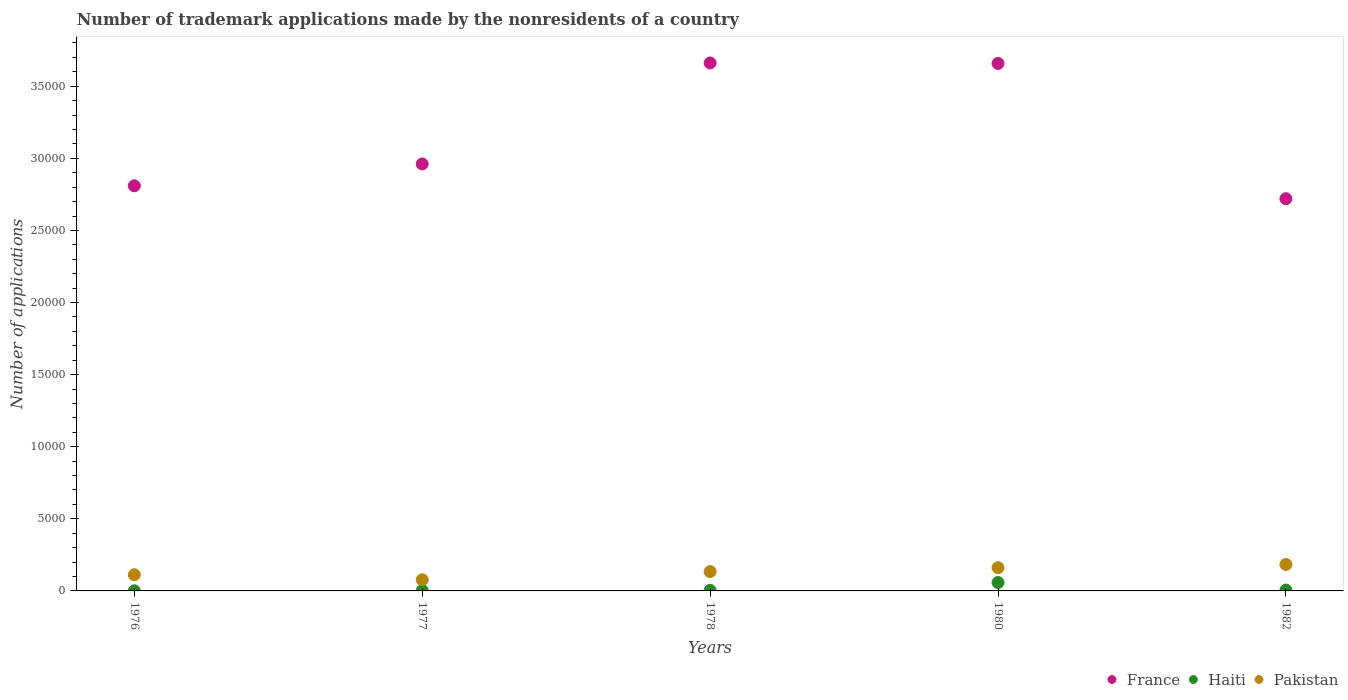Is the number of dotlines equal to the number of legend labels?
Ensure brevity in your answer.  Yes. What is the number of trademark applications made by the nonresidents in France in 1982?
Your answer should be very brief. 2.72e+04. Across all years, what is the maximum number of trademark applications made by the nonresidents in France?
Your response must be concise. 3.66e+04. In which year was the number of trademark applications made by the nonresidents in France maximum?
Ensure brevity in your answer.  1978. In which year was the number of trademark applications made by the nonresidents in Haiti minimum?
Provide a short and direct response. 1976. What is the total number of trademark applications made by the nonresidents in France in the graph?
Offer a terse response. 1.58e+05. What is the difference between the number of trademark applications made by the nonresidents in Pakistan in 1976 and that in 1977?
Offer a very short reply. 347. What is the difference between the number of trademark applications made by the nonresidents in Haiti in 1980 and the number of trademark applications made by the nonresidents in Pakistan in 1976?
Your answer should be compact. -541. What is the average number of trademark applications made by the nonresidents in France per year?
Offer a terse response. 3.16e+04. In the year 1978, what is the difference between the number of trademark applications made by the nonresidents in Haiti and number of trademark applications made by the nonresidents in Pakistan?
Provide a short and direct response. -1304. In how many years, is the number of trademark applications made by the nonresidents in Pakistan greater than 34000?
Give a very brief answer. 0. What is the ratio of the number of trademark applications made by the nonresidents in Haiti in 1977 to that in 1980?
Your answer should be very brief. 0.05. What is the difference between the highest and the lowest number of trademark applications made by the nonresidents in France?
Your response must be concise. 9414. Is the number of trademark applications made by the nonresidents in France strictly greater than the number of trademark applications made by the nonresidents in Pakistan over the years?
Make the answer very short. Yes. How many dotlines are there?
Your answer should be very brief. 3. How many years are there in the graph?
Provide a short and direct response. 5. Are the values on the major ticks of Y-axis written in scientific E-notation?
Your answer should be compact. No. Does the graph contain grids?
Provide a succinct answer. No. How many legend labels are there?
Make the answer very short. 3. How are the legend labels stacked?
Your response must be concise. Horizontal. What is the title of the graph?
Your answer should be very brief. Number of trademark applications made by the nonresidents of a country. What is the label or title of the Y-axis?
Offer a terse response. Number of applications. What is the Number of applications in France in 1976?
Ensure brevity in your answer.  2.81e+04. What is the Number of applications of Pakistan in 1976?
Offer a terse response. 1123. What is the Number of applications of France in 1977?
Your response must be concise. 2.96e+04. What is the Number of applications in Pakistan in 1977?
Your answer should be very brief. 776. What is the Number of applications of France in 1978?
Your answer should be very brief. 3.66e+04. What is the Number of applications of Haiti in 1978?
Your answer should be compact. 36. What is the Number of applications of Pakistan in 1978?
Your answer should be very brief. 1340. What is the Number of applications in France in 1980?
Keep it short and to the point. 3.66e+04. What is the Number of applications in Haiti in 1980?
Ensure brevity in your answer.  582. What is the Number of applications in Pakistan in 1980?
Give a very brief answer. 1611. What is the Number of applications of France in 1982?
Provide a short and direct response. 2.72e+04. What is the Number of applications in Pakistan in 1982?
Ensure brevity in your answer.  1835. Across all years, what is the maximum Number of applications of France?
Give a very brief answer. 3.66e+04. Across all years, what is the maximum Number of applications in Haiti?
Keep it short and to the point. 582. Across all years, what is the maximum Number of applications in Pakistan?
Offer a very short reply. 1835. Across all years, what is the minimum Number of applications of France?
Provide a short and direct response. 2.72e+04. Across all years, what is the minimum Number of applications of Pakistan?
Make the answer very short. 776. What is the total Number of applications of France in the graph?
Keep it short and to the point. 1.58e+05. What is the total Number of applications of Haiti in the graph?
Make the answer very short. 716. What is the total Number of applications of Pakistan in the graph?
Offer a very short reply. 6685. What is the difference between the Number of applications in France in 1976 and that in 1977?
Your answer should be compact. -1515. What is the difference between the Number of applications in Haiti in 1976 and that in 1977?
Your answer should be very brief. -20. What is the difference between the Number of applications in Pakistan in 1976 and that in 1977?
Your answer should be compact. 347. What is the difference between the Number of applications of France in 1976 and that in 1978?
Provide a short and direct response. -8519. What is the difference between the Number of applications in Pakistan in 1976 and that in 1978?
Offer a very short reply. -217. What is the difference between the Number of applications in France in 1976 and that in 1980?
Offer a very short reply. -8485. What is the difference between the Number of applications in Haiti in 1976 and that in 1980?
Make the answer very short. -573. What is the difference between the Number of applications of Pakistan in 1976 and that in 1980?
Your answer should be compact. -488. What is the difference between the Number of applications of France in 1976 and that in 1982?
Provide a succinct answer. 895. What is the difference between the Number of applications in Haiti in 1976 and that in 1982?
Ensure brevity in your answer.  -51. What is the difference between the Number of applications of Pakistan in 1976 and that in 1982?
Keep it short and to the point. -712. What is the difference between the Number of applications in France in 1977 and that in 1978?
Your answer should be compact. -7004. What is the difference between the Number of applications in Pakistan in 1977 and that in 1978?
Make the answer very short. -564. What is the difference between the Number of applications in France in 1977 and that in 1980?
Give a very brief answer. -6970. What is the difference between the Number of applications in Haiti in 1977 and that in 1980?
Your answer should be compact. -553. What is the difference between the Number of applications in Pakistan in 1977 and that in 1980?
Ensure brevity in your answer.  -835. What is the difference between the Number of applications of France in 1977 and that in 1982?
Provide a succinct answer. 2410. What is the difference between the Number of applications of Haiti in 1977 and that in 1982?
Provide a short and direct response. -31. What is the difference between the Number of applications of Pakistan in 1977 and that in 1982?
Your response must be concise. -1059. What is the difference between the Number of applications in Haiti in 1978 and that in 1980?
Give a very brief answer. -546. What is the difference between the Number of applications of Pakistan in 1978 and that in 1980?
Your answer should be compact. -271. What is the difference between the Number of applications in France in 1978 and that in 1982?
Offer a very short reply. 9414. What is the difference between the Number of applications of Haiti in 1978 and that in 1982?
Provide a succinct answer. -24. What is the difference between the Number of applications in Pakistan in 1978 and that in 1982?
Make the answer very short. -495. What is the difference between the Number of applications in France in 1980 and that in 1982?
Give a very brief answer. 9380. What is the difference between the Number of applications in Haiti in 1980 and that in 1982?
Offer a very short reply. 522. What is the difference between the Number of applications in Pakistan in 1980 and that in 1982?
Make the answer very short. -224. What is the difference between the Number of applications of France in 1976 and the Number of applications of Haiti in 1977?
Provide a succinct answer. 2.81e+04. What is the difference between the Number of applications of France in 1976 and the Number of applications of Pakistan in 1977?
Provide a succinct answer. 2.73e+04. What is the difference between the Number of applications in Haiti in 1976 and the Number of applications in Pakistan in 1977?
Your answer should be very brief. -767. What is the difference between the Number of applications in France in 1976 and the Number of applications in Haiti in 1978?
Provide a short and direct response. 2.81e+04. What is the difference between the Number of applications of France in 1976 and the Number of applications of Pakistan in 1978?
Your answer should be compact. 2.68e+04. What is the difference between the Number of applications in Haiti in 1976 and the Number of applications in Pakistan in 1978?
Your answer should be very brief. -1331. What is the difference between the Number of applications of France in 1976 and the Number of applications of Haiti in 1980?
Provide a short and direct response. 2.75e+04. What is the difference between the Number of applications in France in 1976 and the Number of applications in Pakistan in 1980?
Give a very brief answer. 2.65e+04. What is the difference between the Number of applications in Haiti in 1976 and the Number of applications in Pakistan in 1980?
Offer a terse response. -1602. What is the difference between the Number of applications in France in 1976 and the Number of applications in Haiti in 1982?
Your answer should be very brief. 2.80e+04. What is the difference between the Number of applications in France in 1976 and the Number of applications in Pakistan in 1982?
Keep it short and to the point. 2.63e+04. What is the difference between the Number of applications of Haiti in 1976 and the Number of applications of Pakistan in 1982?
Provide a succinct answer. -1826. What is the difference between the Number of applications in France in 1977 and the Number of applications in Haiti in 1978?
Keep it short and to the point. 2.96e+04. What is the difference between the Number of applications of France in 1977 and the Number of applications of Pakistan in 1978?
Provide a short and direct response. 2.83e+04. What is the difference between the Number of applications of Haiti in 1977 and the Number of applications of Pakistan in 1978?
Give a very brief answer. -1311. What is the difference between the Number of applications of France in 1977 and the Number of applications of Haiti in 1980?
Provide a short and direct response. 2.90e+04. What is the difference between the Number of applications of France in 1977 and the Number of applications of Pakistan in 1980?
Give a very brief answer. 2.80e+04. What is the difference between the Number of applications in Haiti in 1977 and the Number of applications in Pakistan in 1980?
Give a very brief answer. -1582. What is the difference between the Number of applications of France in 1977 and the Number of applications of Haiti in 1982?
Offer a terse response. 2.96e+04. What is the difference between the Number of applications of France in 1977 and the Number of applications of Pakistan in 1982?
Provide a short and direct response. 2.78e+04. What is the difference between the Number of applications in Haiti in 1977 and the Number of applications in Pakistan in 1982?
Your answer should be very brief. -1806. What is the difference between the Number of applications in France in 1978 and the Number of applications in Haiti in 1980?
Provide a short and direct response. 3.60e+04. What is the difference between the Number of applications in France in 1978 and the Number of applications in Pakistan in 1980?
Ensure brevity in your answer.  3.50e+04. What is the difference between the Number of applications of Haiti in 1978 and the Number of applications of Pakistan in 1980?
Your response must be concise. -1575. What is the difference between the Number of applications in France in 1978 and the Number of applications in Haiti in 1982?
Provide a short and direct response. 3.66e+04. What is the difference between the Number of applications of France in 1978 and the Number of applications of Pakistan in 1982?
Your answer should be compact. 3.48e+04. What is the difference between the Number of applications in Haiti in 1978 and the Number of applications in Pakistan in 1982?
Your answer should be compact. -1799. What is the difference between the Number of applications in France in 1980 and the Number of applications in Haiti in 1982?
Provide a short and direct response. 3.65e+04. What is the difference between the Number of applications in France in 1980 and the Number of applications in Pakistan in 1982?
Give a very brief answer. 3.47e+04. What is the difference between the Number of applications in Haiti in 1980 and the Number of applications in Pakistan in 1982?
Your answer should be compact. -1253. What is the average Number of applications in France per year?
Provide a succinct answer. 3.16e+04. What is the average Number of applications of Haiti per year?
Keep it short and to the point. 143.2. What is the average Number of applications in Pakistan per year?
Offer a very short reply. 1337. In the year 1976, what is the difference between the Number of applications in France and Number of applications in Haiti?
Provide a succinct answer. 2.81e+04. In the year 1976, what is the difference between the Number of applications of France and Number of applications of Pakistan?
Make the answer very short. 2.70e+04. In the year 1976, what is the difference between the Number of applications of Haiti and Number of applications of Pakistan?
Your answer should be very brief. -1114. In the year 1977, what is the difference between the Number of applications in France and Number of applications in Haiti?
Your response must be concise. 2.96e+04. In the year 1977, what is the difference between the Number of applications of France and Number of applications of Pakistan?
Provide a succinct answer. 2.88e+04. In the year 1977, what is the difference between the Number of applications in Haiti and Number of applications in Pakistan?
Keep it short and to the point. -747. In the year 1978, what is the difference between the Number of applications of France and Number of applications of Haiti?
Give a very brief answer. 3.66e+04. In the year 1978, what is the difference between the Number of applications of France and Number of applications of Pakistan?
Offer a terse response. 3.53e+04. In the year 1978, what is the difference between the Number of applications of Haiti and Number of applications of Pakistan?
Make the answer very short. -1304. In the year 1980, what is the difference between the Number of applications in France and Number of applications in Haiti?
Ensure brevity in your answer.  3.60e+04. In the year 1980, what is the difference between the Number of applications of France and Number of applications of Pakistan?
Make the answer very short. 3.50e+04. In the year 1980, what is the difference between the Number of applications in Haiti and Number of applications in Pakistan?
Give a very brief answer. -1029. In the year 1982, what is the difference between the Number of applications in France and Number of applications in Haiti?
Offer a terse response. 2.71e+04. In the year 1982, what is the difference between the Number of applications in France and Number of applications in Pakistan?
Your answer should be compact. 2.54e+04. In the year 1982, what is the difference between the Number of applications in Haiti and Number of applications in Pakistan?
Your answer should be compact. -1775. What is the ratio of the Number of applications in France in 1976 to that in 1977?
Ensure brevity in your answer.  0.95. What is the ratio of the Number of applications in Haiti in 1976 to that in 1977?
Make the answer very short. 0.31. What is the ratio of the Number of applications of Pakistan in 1976 to that in 1977?
Provide a succinct answer. 1.45. What is the ratio of the Number of applications of France in 1976 to that in 1978?
Your answer should be very brief. 0.77. What is the ratio of the Number of applications of Pakistan in 1976 to that in 1978?
Provide a succinct answer. 0.84. What is the ratio of the Number of applications of France in 1976 to that in 1980?
Your answer should be very brief. 0.77. What is the ratio of the Number of applications of Haiti in 1976 to that in 1980?
Your answer should be compact. 0.02. What is the ratio of the Number of applications of Pakistan in 1976 to that in 1980?
Give a very brief answer. 0.7. What is the ratio of the Number of applications of France in 1976 to that in 1982?
Your response must be concise. 1.03. What is the ratio of the Number of applications of Pakistan in 1976 to that in 1982?
Your response must be concise. 0.61. What is the ratio of the Number of applications in France in 1977 to that in 1978?
Your response must be concise. 0.81. What is the ratio of the Number of applications of Haiti in 1977 to that in 1978?
Provide a short and direct response. 0.81. What is the ratio of the Number of applications in Pakistan in 1977 to that in 1978?
Provide a short and direct response. 0.58. What is the ratio of the Number of applications in France in 1977 to that in 1980?
Offer a terse response. 0.81. What is the ratio of the Number of applications in Haiti in 1977 to that in 1980?
Provide a short and direct response. 0.05. What is the ratio of the Number of applications of Pakistan in 1977 to that in 1980?
Your answer should be compact. 0.48. What is the ratio of the Number of applications in France in 1977 to that in 1982?
Your answer should be very brief. 1.09. What is the ratio of the Number of applications of Haiti in 1977 to that in 1982?
Give a very brief answer. 0.48. What is the ratio of the Number of applications of Pakistan in 1977 to that in 1982?
Give a very brief answer. 0.42. What is the ratio of the Number of applications of Haiti in 1978 to that in 1980?
Offer a very short reply. 0.06. What is the ratio of the Number of applications in Pakistan in 1978 to that in 1980?
Make the answer very short. 0.83. What is the ratio of the Number of applications in France in 1978 to that in 1982?
Provide a succinct answer. 1.35. What is the ratio of the Number of applications of Haiti in 1978 to that in 1982?
Provide a succinct answer. 0.6. What is the ratio of the Number of applications of Pakistan in 1978 to that in 1982?
Keep it short and to the point. 0.73. What is the ratio of the Number of applications in France in 1980 to that in 1982?
Offer a very short reply. 1.34. What is the ratio of the Number of applications of Haiti in 1980 to that in 1982?
Provide a short and direct response. 9.7. What is the ratio of the Number of applications of Pakistan in 1980 to that in 1982?
Give a very brief answer. 0.88. What is the difference between the highest and the second highest Number of applications of Haiti?
Provide a short and direct response. 522. What is the difference between the highest and the second highest Number of applications in Pakistan?
Your answer should be very brief. 224. What is the difference between the highest and the lowest Number of applications in France?
Offer a very short reply. 9414. What is the difference between the highest and the lowest Number of applications in Haiti?
Offer a very short reply. 573. What is the difference between the highest and the lowest Number of applications in Pakistan?
Make the answer very short. 1059. 